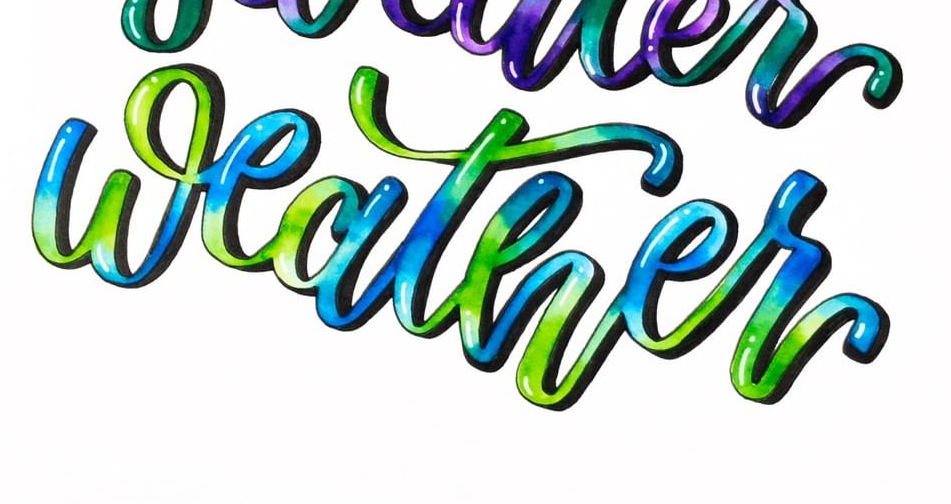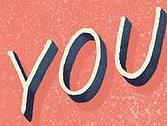Transcribe the words shown in these images in order, separated by a semicolon. weather; YOU 